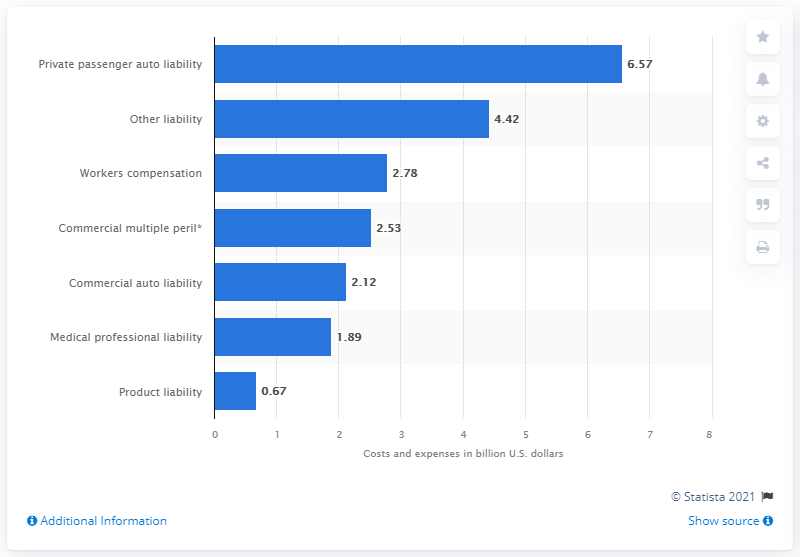Mention a couple of crucial points in this snapshot. The settlement expenses of U.S. insurers in the private passenger auto liability line amounted to 6.57 in 2019. 